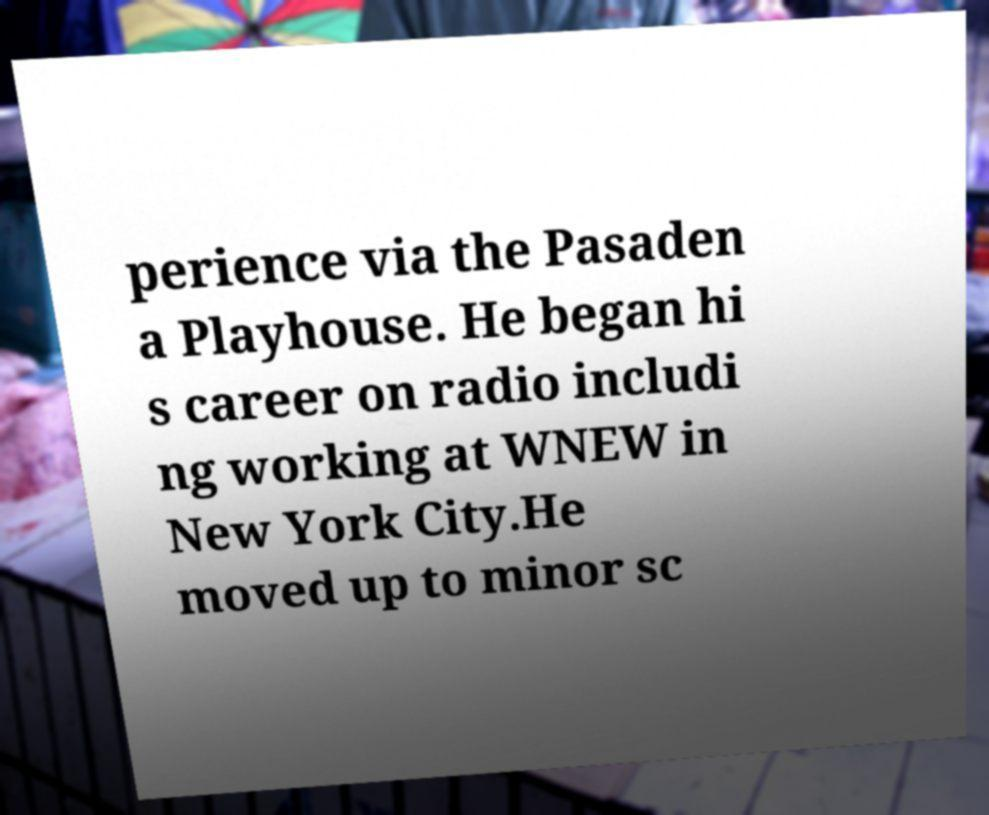Please read and relay the text visible in this image. What does it say? perience via the Pasaden a Playhouse. He began hi s career on radio includi ng working at WNEW in New York City.He moved up to minor sc 